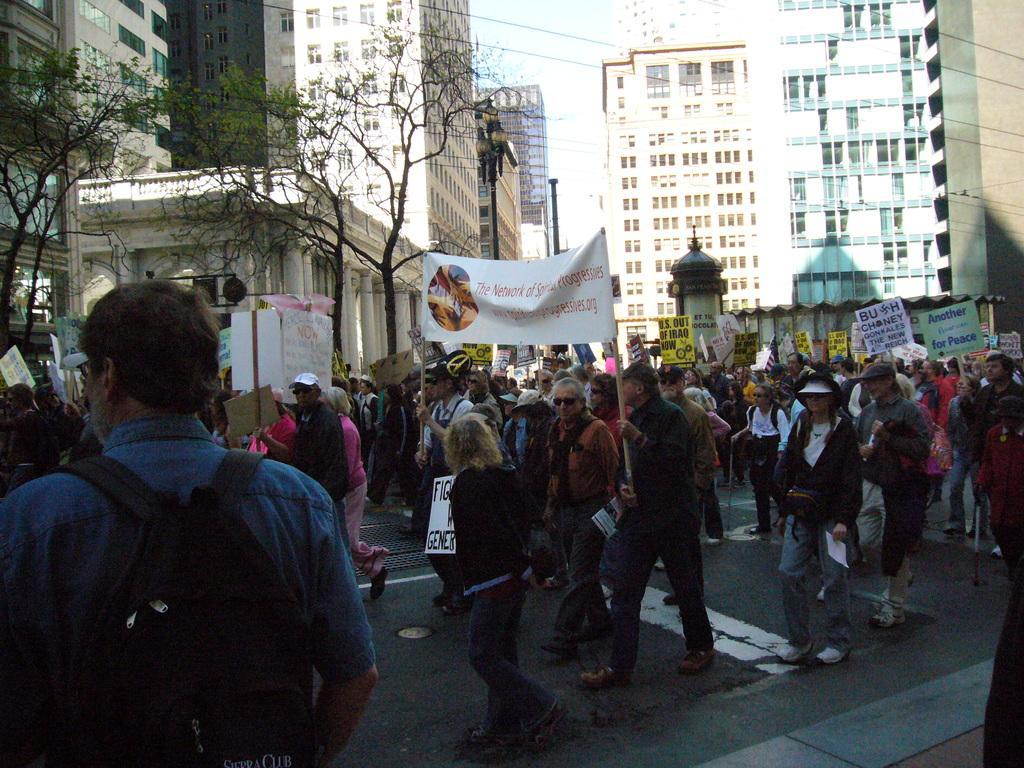Please provide a concise description of this image. In the center of the image there are people walking. In the background of the image there are buildings. There are trees. At the bottom of the image there is road. 